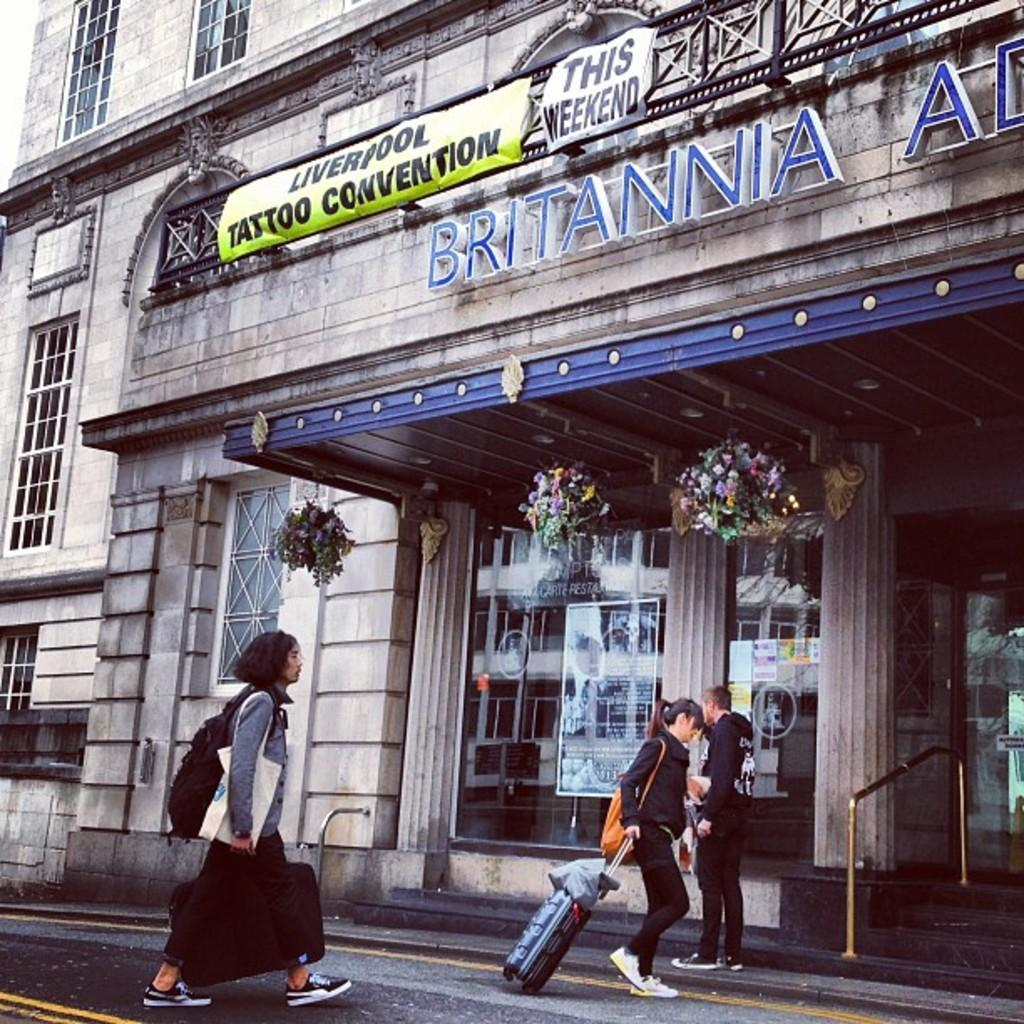What are the two persons in the image doing? The two persons in the image are walking. What is the man in the image doing? The man in the image is standing. What structure is visible in the image? There is a building in the image. What is written on the building? The word "BRITANNIA" is written on the building. What type of windows are on the building? There are glass windows on the building. What type of loaf is being used to hold the building together in the image? There is no loaf present in the image, and it is not being used to hold the building together. 